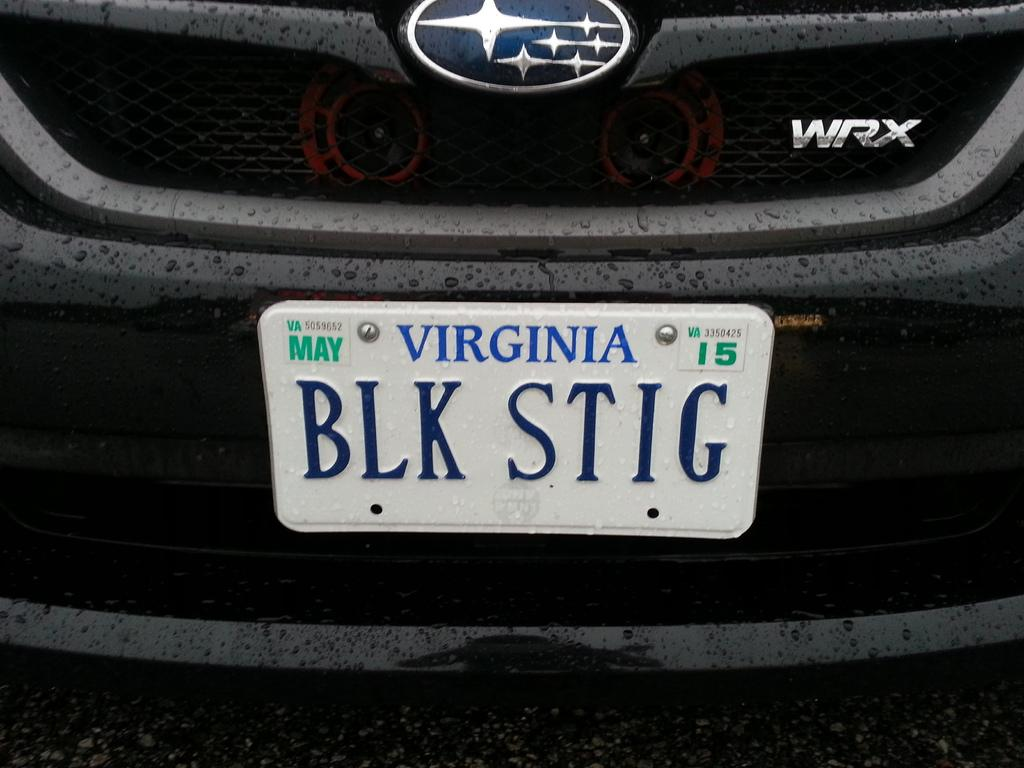<image>
Present a compact description of the photo's key features. the word virginia is on a license plate 